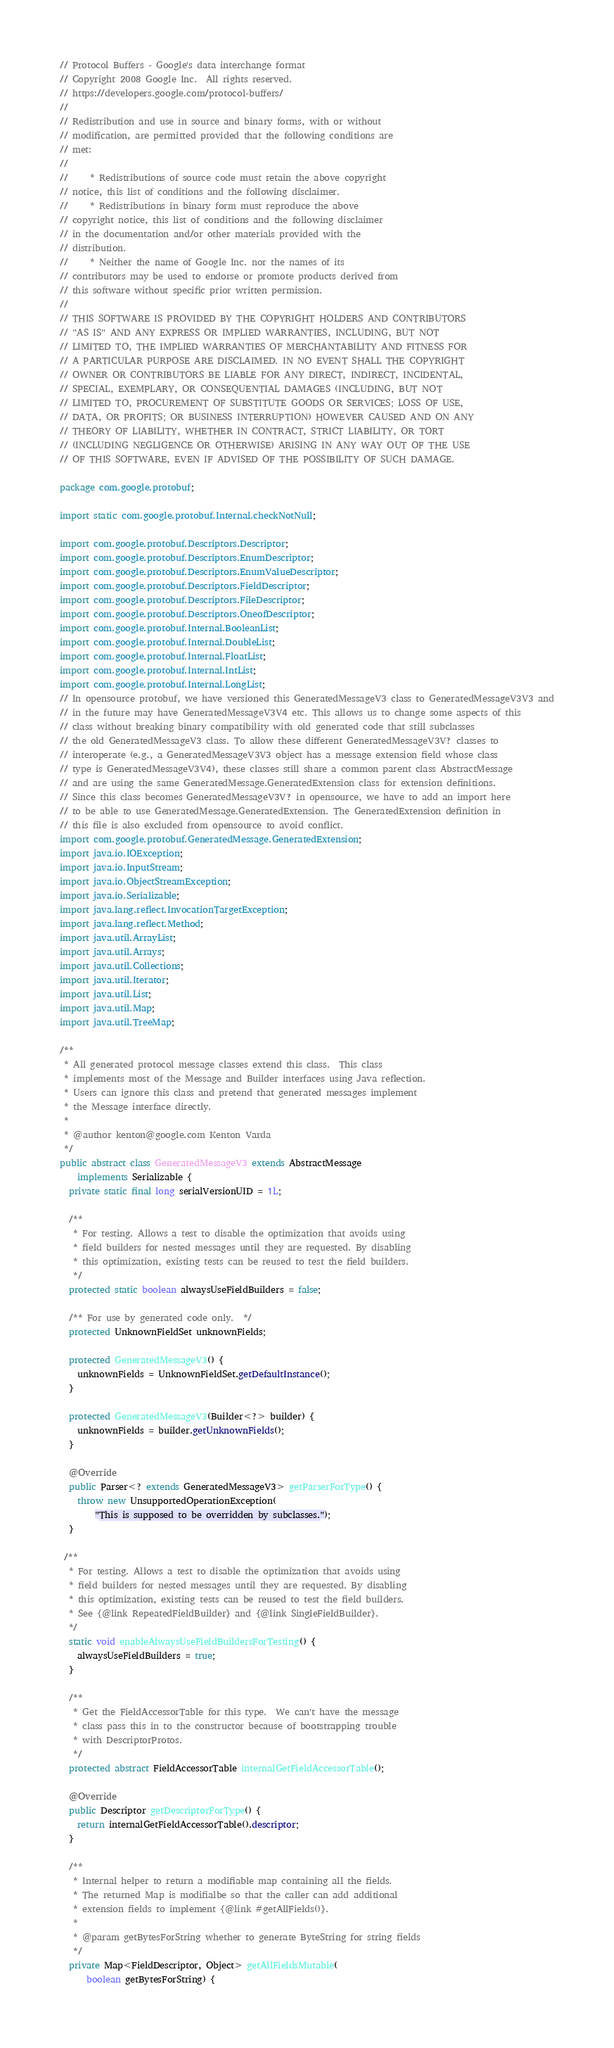Convert code to text. <code><loc_0><loc_0><loc_500><loc_500><_Java_>// Protocol Buffers - Google's data interchange format
// Copyright 2008 Google Inc.  All rights reserved.
// https://developers.google.com/protocol-buffers/
//
// Redistribution and use in source and binary forms, with or without
// modification, are permitted provided that the following conditions are
// met:
//
//     * Redistributions of source code must retain the above copyright
// notice, this list of conditions and the following disclaimer.
//     * Redistributions in binary form must reproduce the above
// copyright notice, this list of conditions and the following disclaimer
// in the documentation and/or other materials provided with the
// distribution.
//     * Neither the name of Google Inc. nor the names of its
// contributors may be used to endorse or promote products derived from
// this software without specific prior written permission.
//
// THIS SOFTWARE IS PROVIDED BY THE COPYRIGHT HOLDERS AND CONTRIBUTORS
// "AS IS" AND ANY EXPRESS OR IMPLIED WARRANTIES, INCLUDING, BUT NOT
// LIMITED TO, THE IMPLIED WARRANTIES OF MERCHANTABILITY AND FITNESS FOR
// A PARTICULAR PURPOSE ARE DISCLAIMED. IN NO EVENT SHALL THE COPYRIGHT
// OWNER OR CONTRIBUTORS BE LIABLE FOR ANY DIRECT, INDIRECT, INCIDENTAL,
// SPECIAL, EXEMPLARY, OR CONSEQUENTIAL DAMAGES (INCLUDING, BUT NOT
// LIMITED TO, PROCUREMENT OF SUBSTITUTE GOODS OR SERVICES; LOSS OF USE,
// DATA, OR PROFITS; OR BUSINESS INTERRUPTION) HOWEVER CAUSED AND ON ANY
// THEORY OF LIABILITY, WHETHER IN CONTRACT, STRICT LIABILITY, OR TORT
// (INCLUDING NEGLIGENCE OR OTHERWISE) ARISING IN ANY WAY OUT OF THE USE
// OF THIS SOFTWARE, EVEN IF ADVISED OF THE POSSIBILITY OF SUCH DAMAGE.

package com.google.protobuf;

import static com.google.protobuf.Internal.checkNotNull;

import com.google.protobuf.Descriptors.Descriptor;
import com.google.protobuf.Descriptors.EnumDescriptor;
import com.google.protobuf.Descriptors.EnumValueDescriptor;
import com.google.protobuf.Descriptors.FieldDescriptor;
import com.google.protobuf.Descriptors.FileDescriptor;
import com.google.protobuf.Descriptors.OneofDescriptor;
import com.google.protobuf.Internal.BooleanList;
import com.google.protobuf.Internal.DoubleList;
import com.google.protobuf.Internal.FloatList;
import com.google.protobuf.Internal.IntList;
import com.google.protobuf.Internal.LongList;
// In opensource protobuf, we have versioned this GeneratedMessageV3 class to GeneratedMessageV3V3 and
// in the future may have GeneratedMessageV3V4 etc. This allows us to change some aspects of this
// class without breaking binary compatibility with old generated code that still subclasses
// the old GeneratedMessageV3 class. To allow these different GeneratedMessageV3V? classes to
// interoperate (e.g., a GeneratedMessageV3V3 object has a message extension field whose class
// type is GeneratedMessageV3V4), these classes still share a common parent class AbstractMessage
// and are using the same GeneratedMessage.GeneratedExtension class for extension definitions.
// Since this class becomes GeneratedMessageV3V? in opensource, we have to add an import here
// to be able to use GeneratedMessage.GeneratedExtension. The GeneratedExtension definition in
// this file is also excluded from opensource to avoid conflict.
import com.google.protobuf.GeneratedMessage.GeneratedExtension;
import java.io.IOException;
import java.io.InputStream;
import java.io.ObjectStreamException;
import java.io.Serializable;
import java.lang.reflect.InvocationTargetException;
import java.lang.reflect.Method;
import java.util.ArrayList;
import java.util.Arrays;
import java.util.Collections;
import java.util.Iterator;
import java.util.List;
import java.util.Map;
import java.util.TreeMap;

/**
 * All generated protocol message classes extend this class.  This class
 * implements most of the Message and Builder interfaces using Java reflection.
 * Users can ignore this class and pretend that generated messages implement
 * the Message interface directly.
 *
 * @author kenton@google.com Kenton Varda
 */
public abstract class GeneratedMessageV3 extends AbstractMessage
    implements Serializable {
  private static final long serialVersionUID = 1L;

  /**
   * For testing. Allows a test to disable the optimization that avoids using
   * field builders for nested messages until they are requested. By disabling
   * this optimization, existing tests can be reused to test the field builders.
   */
  protected static boolean alwaysUseFieldBuilders = false;

  /** For use by generated code only.  */
  protected UnknownFieldSet unknownFields;

  protected GeneratedMessageV3() {
    unknownFields = UnknownFieldSet.getDefaultInstance();
  }

  protected GeneratedMessageV3(Builder<?> builder) {
    unknownFields = builder.getUnknownFields();
  }

  @Override
  public Parser<? extends GeneratedMessageV3> getParserForType() {
    throw new UnsupportedOperationException(
        "This is supposed to be overridden by subclasses.");
  }

 /**
  * For testing. Allows a test to disable the optimization that avoids using
  * field builders for nested messages until they are requested. By disabling
  * this optimization, existing tests can be reused to test the field builders.
  * See {@link RepeatedFieldBuilder} and {@link SingleFieldBuilder}.
  */
  static void enableAlwaysUseFieldBuildersForTesting() {
    alwaysUseFieldBuilders = true;
  }

  /**
   * Get the FieldAccessorTable for this type.  We can't have the message
   * class pass this in to the constructor because of bootstrapping trouble
   * with DescriptorProtos.
   */
  protected abstract FieldAccessorTable internalGetFieldAccessorTable();

  @Override
  public Descriptor getDescriptorForType() {
    return internalGetFieldAccessorTable().descriptor;
  }

  /**
   * Internal helper to return a modifiable map containing all the fields.
   * The returned Map is modifialbe so that the caller can add additional
   * extension fields to implement {@link #getAllFields()}.
   *
   * @param getBytesForString whether to generate ByteString for string fields
   */
  private Map<FieldDescriptor, Object> getAllFieldsMutable(
      boolean getBytesForString) {</code> 